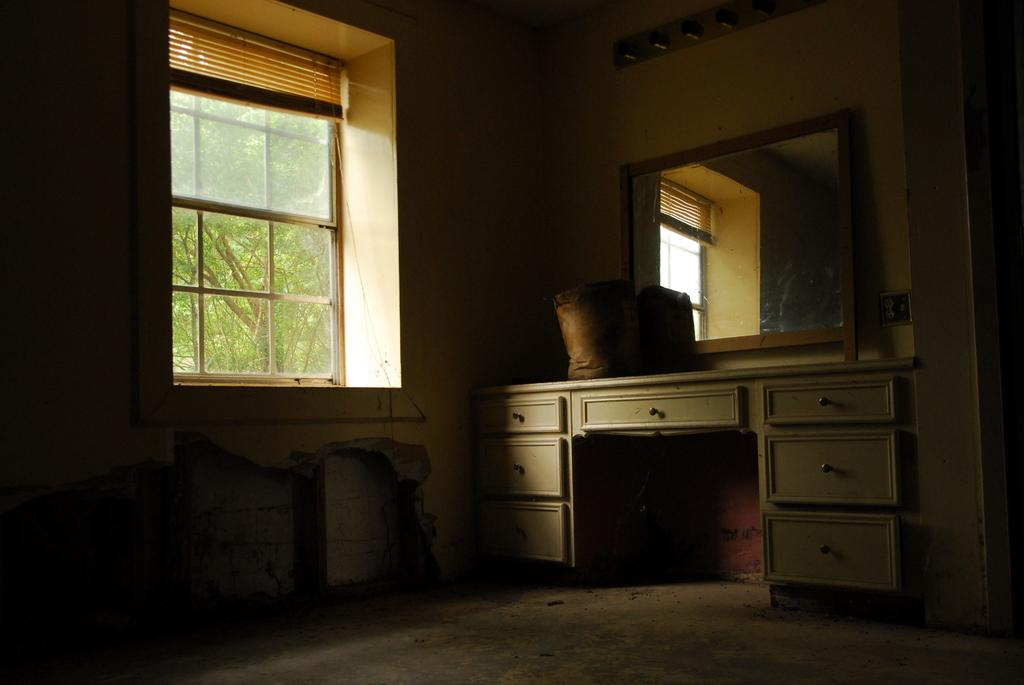What type of furniture is present in the image? There are cupboards in the image. What can be seen on top of the cupboards? There are objects on the cupboards. What reflective surface is present in the image? There is a mirror in the image. What architectural feature is visible in the image? There is a window in the image. What type of window treatment is present in the image? There are curtains associated with the window. What can be seen outside the window? Trees are visible through the window. How many sisters are visible in the image? There are no sisters present in the image. What type of zebra can be seen interacting with the cupboards in the image? There is no zebra present in the image, and therefore no such interaction can be observed. 